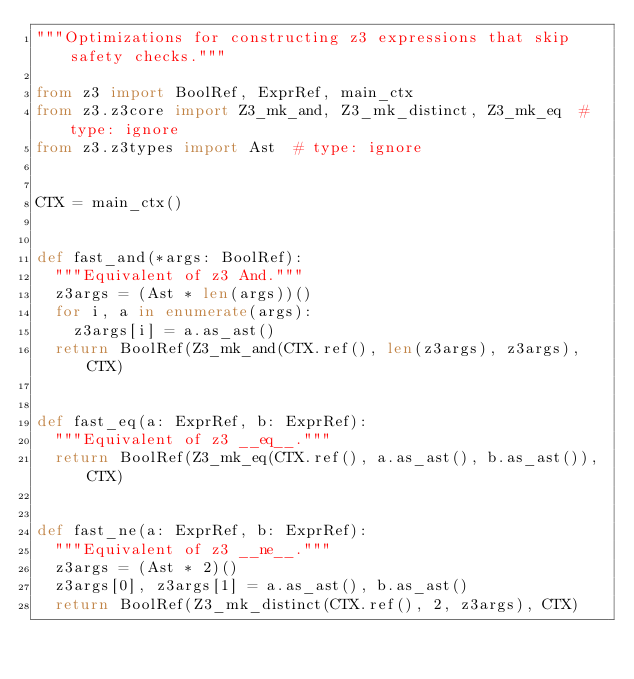<code> <loc_0><loc_0><loc_500><loc_500><_Python_>"""Optimizations for constructing z3 expressions that skip safety checks."""

from z3 import BoolRef, ExprRef, main_ctx
from z3.z3core import Z3_mk_and, Z3_mk_distinct, Z3_mk_eq  # type: ignore
from z3.z3types import Ast  # type: ignore


CTX = main_ctx()


def fast_and(*args: BoolRef):
  """Equivalent of z3 And."""
  z3args = (Ast * len(args))()
  for i, a in enumerate(args):
    z3args[i] = a.as_ast()
  return BoolRef(Z3_mk_and(CTX.ref(), len(z3args), z3args), CTX)


def fast_eq(a: ExprRef, b: ExprRef):
  """Equivalent of z3 __eq__."""
  return BoolRef(Z3_mk_eq(CTX.ref(), a.as_ast(), b.as_ast()), CTX)


def fast_ne(a: ExprRef, b: ExprRef):
  """Equivalent of z3 __ne__."""
  z3args = (Ast * 2)()
  z3args[0], z3args[1] = a.as_ast(), b.as_ast()
  return BoolRef(Z3_mk_distinct(CTX.ref(), 2, z3args), CTX)
</code> 